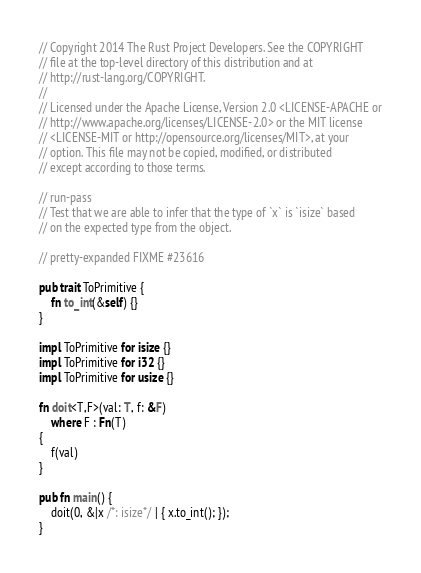Convert code to text. <code><loc_0><loc_0><loc_500><loc_500><_Rust_>// Copyright 2014 The Rust Project Developers. See the COPYRIGHT
// file at the top-level directory of this distribution and at
// http://rust-lang.org/COPYRIGHT.
//
// Licensed under the Apache License, Version 2.0 <LICENSE-APACHE or
// http://www.apache.org/licenses/LICENSE-2.0> or the MIT license
// <LICENSE-MIT or http://opensource.org/licenses/MIT>, at your
// option. This file may not be copied, modified, or distributed
// except according to those terms.

// run-pass
// Test that we are able to infer that the type of `x` is `isize` based
// on the expected type from the object.

// pretty-expanded FIXME #23616

pub trait ToPrimitive {
    fn to_int(&self) {}
}

impl ToPrimitive for isize {}
impl ToPrimitive for i32 {}
impl ToPrimitive for usize {}

fn doit<T,F>(val: T, f: &F)
    where F : Fn(T)
{
    f(val)
}

pub fn main() {
    doit(0, &|x /*: isize*/ | { x.to_int(); });
}
</code> 